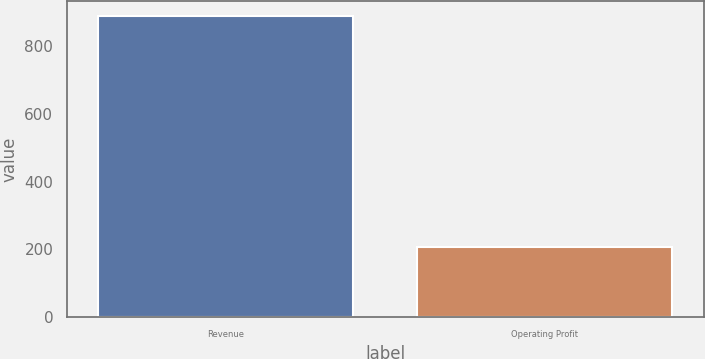Convert chart. <chart><loc_0><loc_0><loc_500><loc_500><bar_chart><fcel>Revenue<fcel>Operating Profit<nl><fcel>889.7<fcel>207<nl></chart> 